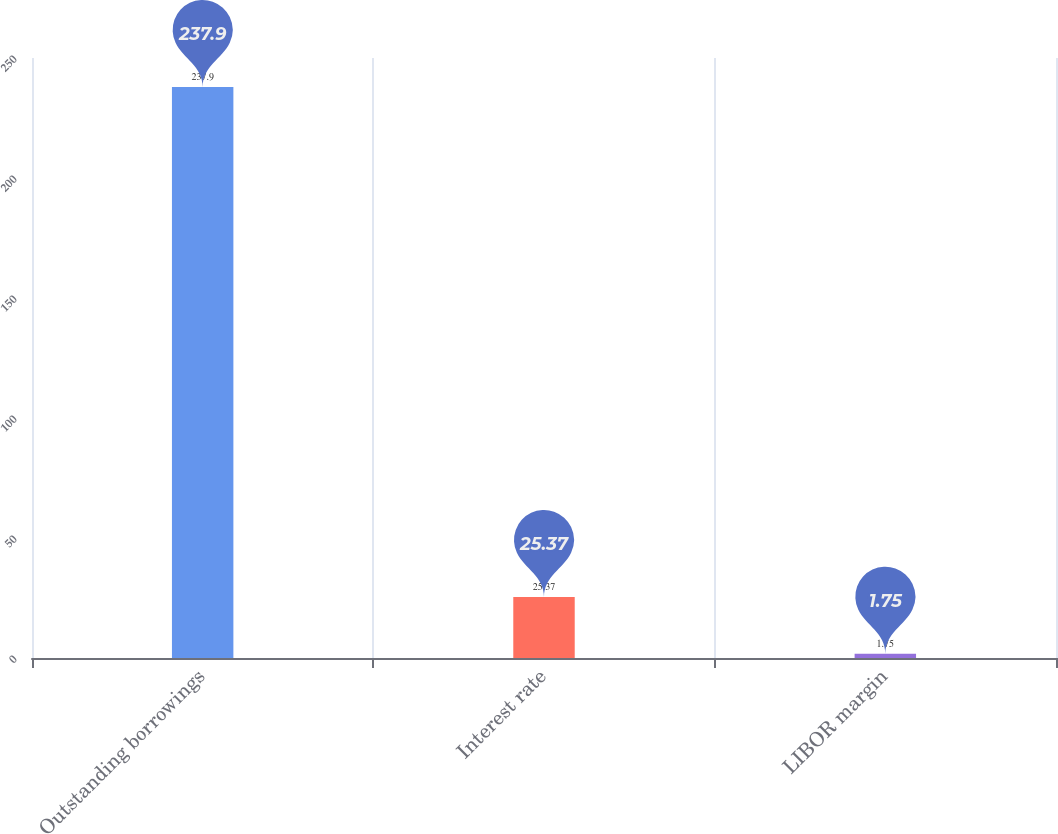<chart> <loc_0><loc_0><loc_500><loc_500><bar_chart><fcel>Outstanding borrowings<fcel>Interest rate<fcel>LIBOR margin<nl><fcel>237.9<fcel>25.37<fcel>1.75<nl></chart> 